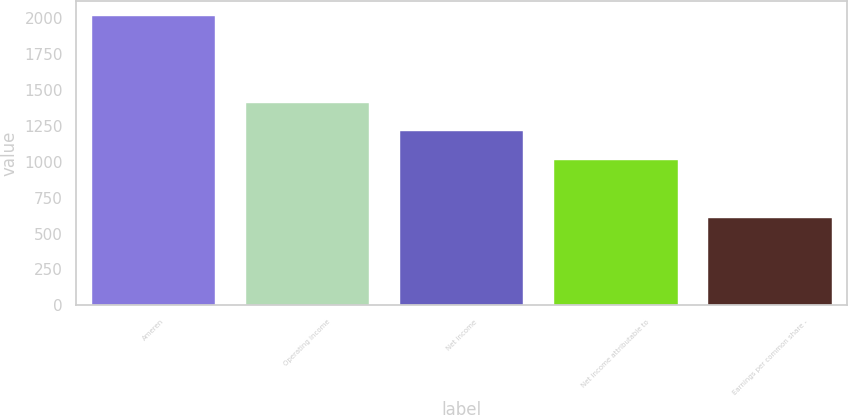<chart> <loc_0><loc_0><loc_500><loc_500><bar_chart><fcel>Ameren<fcel>Operating income<fcel>Net income<fcel>Net income attributable to<fcel>Earnings per common share -<nl><fcel>2015<fcel>1410.62<fcel>1209.16<fcel>1007.7<fcel>604.78<nl></chart> 